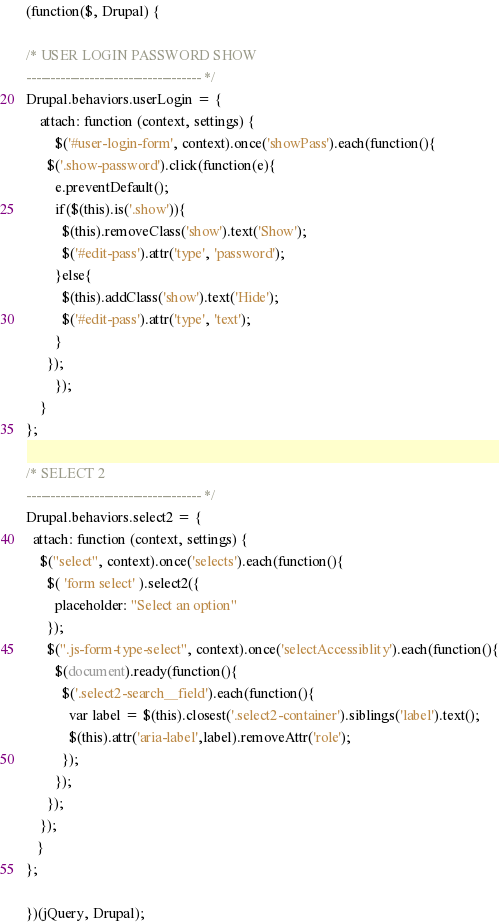<code> <loc_0><loc_0><loc_500><loc_500><_JavaScript_>(function($, Drupal) {

/* USER LOGIN PASSWORD SHOW
------------------------------------ */
Drupal.behaviors.userLogin = {
	attach: function (context, settings) {
		$('#user-login-form', context).once('showPass').each(function(){
      $('.show-password').click(function(e){
        e.preventDefault();
        if($(this).is('.show')){
          $(this).removeClass('show').text('Show');
          $('#edit-pass').attr('type', 'password');
        }else{
          $(this).addClass('show').text('Hide');
          $('#edit-pass').attr('type', 'text');
        }
      });
		});
	}
};

/* SELECT 2
------------------------------------ */
Drupal.behaviors.select2 = {
  attach: function (context, settings) {
    $("select", context).once('selects').each(function(){
      $( 'form select' ).select2({
        placeholder: "Select an option"
      });
      $(".js-form-type-select", context).once('selectAccessiblity').each(function(){
        $(document).ready(function(){
          $('.select2-search__field').each(function(){
            var label = $(this).closest('.select2-container').siblings('label').text();
            $(this).attr('aria-label',label).removeAttr('role');
          });
        });
      });
    });
   }
};

})(jQuery, Drupal);
</code> 